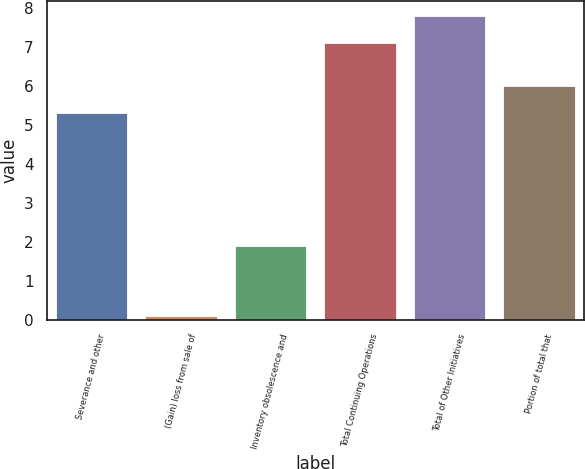Convert chart. <chart><loc_0><loc_0><loc_500><loc_500><bar_chart><fcel>Severance and other<fcel>(Gain) loss from sale of<fcel>Inventory obsolescence and<fcel>Total Continuing Operations<fcel>Total of Other Initiatives<fcel>Portion of total that<nl><fcel>5.3<fcel>0.1<fcel>1.9<fcel>7.1<fcel>7.8<fcel>6<nl></chart> 